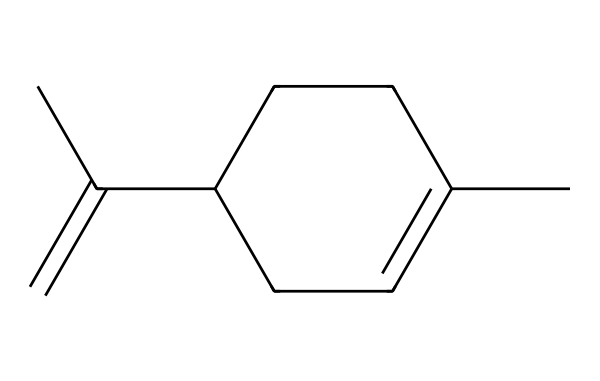What is the molecular formula of limonene? To find the molecular formula, count the atoms represented in the SMILES notation. The SMILES indicates there are 10 carbon atoms and 16 hydrogen atoms. Thus, the molecular formula is C10H16.
Answer: C10H16 How many rings are present in the structure of limonene? By analyzing the SMILES representation, we can see the presence of a cycle indicated by the 'C1' in the structure. Only one cyclic structure is present in limonene, indicating that there is one ring.
Answer: 1 What type of compound is limonene classified as? Limonene has a structure defined by a sequence of carbon and hydrogen atoms that exhibit reactivity typical for terpenes. It belongs to the hydrocarbon category, specifically as a terpene.
Answer: terpene Which functional group is suggested by the presence of double bonds in limonene? The presence of double bonds (C=C) in the structure signifies an alkene functional group. This is typical for many terpenes, which often contain double bonds to enhance reactivity.
Answer: alkene What is the significance of the cycloalkene structure in limonene? The cycloalkene structure in limonene contributes to its aromatic properties, making it fragrant and widely used in flavoring and fragrance industries. It also influences reactivity and interaction with biological systems.
Answer: aromatic properties 